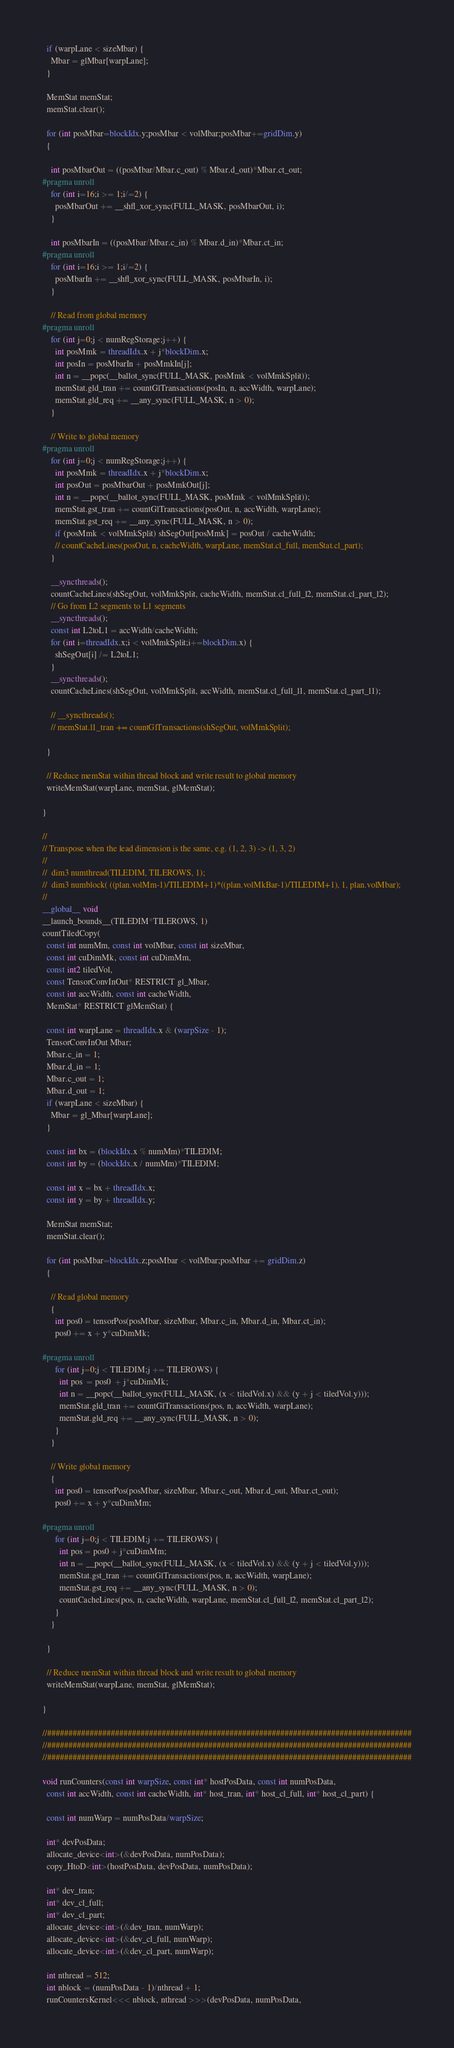Convert code to text. <code><loc_0><loc_0><loc_500><loc_500><_Cuda_>  if (warpLane < sizeMbar) {
    Mbar = glMbar[warpLane];
  }

  MemStat memStat;
  memStat.clear();

  for (int posMbar=blockIdx.y;posMbar < volMbar;posMbar+=gridDim.y)
  {

    int posMbarOut = ((posMbar/Mbar.c_out) % Mbar.d_out)*Mbar.ct_out;
#pragma unroll
    for (int i=16;i >= 1;i/=2) {
      posMbarOut += __shfl_xor_sync(FULL_MASK, posMbarOut, i);
    }

    int posMbarIn = ((posMbar/Mbar.c_in) % Mbar.d_in)*Mbar.ct_in;
#pragma unroll
    for (int i=16;i >= 1;i/=2) {
      posMbarIn += __shfl_xor_sync(FULL_MASK, posMbarIn, i);
    }

    // Read from global memory
#pragma unroll
    for (int j=0;j < numRegStorage;j++) {
      int posMmk = threadIdx.x + j*blockDim.x;
      int posIn = posMbarIn + posMmkIn[j];
      int n = __popc(__ballot_sync(FULL_MASK, posMmk < volMmkSplit));
      memStat.gld_tran += countGlTransactions(posIn, n, accWidth, warpLane);
      memStat.gld_req += __any_sync(FULL_MASK, n > 0);
    }

    // Write to global memory
#pragma unroll
    for (int j=0;j < numRegStorage;j++) {
      int posMmk = threadIdx.x + j*blockDim.x;
      int posOut = posMbarOut + posMmkOut[j];
      int n = __popc(__ballot_sync(FULL_MASK, posMmk < volMmkSplit));
      memStat.gst_tran += countGlTransactions(posOut, n, accWidth, warpLane);
      memStat.gst_req += __any_sync(FULL_MASK, n > 0);
      if (posMmk < volMmkSplit) shSegOut[posMmk] = posOut / cacheWidth;
      // countCacheLines(posOut, n, cacheWidth, warpLane, memStat.cl_full, memStat.cl_part);
    }

    __syncthreads();
    countCacheLines(shSegOut, volMmkSplit, cacheWidth, memStat.cl_full_l2, memStat.cl_part_l2);
    // Go from L2 segments to L1 segments
    __syncthreads();
    const int L2toL1 = accWidth/cacheWidth;
    for (int i=threadIdx.x;i < volMmkSplit;i+=blockDim.x) {
      shSegOut[i] /= L2toL1;
    }
    __syncthreads();
    countCacheLines(shSegOut, volMmkSplit, accWidth, memStat.cl_full_l1, memStat.cl_part_l1);

    // __syncthreads();
    // memStat.l1_tran += countGlTransactions(shSegOut, volMmkSplit);

  }

  // Reduce memStat within thread block and write result to global memory
  writeMemStat(warpLane, memStat, glMemStat);

}

//
// Transpose when the lead dimension is the same, e.g. (1, 2, 3) -> (1, 3, 2)
//
//  dim3 numthread(TILEDIM, TILEROWS, 1);
//  dim3 numblock( ((plan.volMm-1)/TILEDIM+1)*((plan.volMkBar-1)/TILEDIM+1), 1, plan.volMbar);
//
__global__ void
__launch_bounds__(TILEDIM*TILEROWS, 1)
countTiledCopy(
  const int numMm, const int volMbar, const int sizeMbar,
  const int cuDimMk, const int cuDimMm,
  const int2 tiledVol,
  const TensorConvInOut* RESTRICT gl_Mbar,
  const int accWidth, const int cacheWidth,
  MemStat* RESTRICT glMemStat) {

  const int warpLane = threadIdx.x & (warpSize - 1);
  TensorConvInOut Mbar;
  Mbar.c_in = 1;
  Mbar.d_in = 1;
  Mbar.c_out = 1;
  Mbar.d_out = 1;
  if (warpLane < sizeMbar) {
    Mbar = gl_Mbar[warpLane];
  }

  const int bx = (blockIdx.x % numMm)*TILEDIM;
  const int by = (blockIdx.x / numMm)*TILEDIM;

  const int x = bx + threadIdx.x;
  const int y = by + threadIdx.y;

  MemStat memStat;
  memStat.clear();

  for (int posMbar=blockIdx.z;posMbar < volMbar;posMbar += gridDim.z)
  {

    // Read global memory
    {
      int pos0 = tensorPos(posMbar, sizeMbar, Mbar.c_in, Mbar.d_in, Mbar.ct_in);
      pos0 += x + y*cuDimMk;

#pragma unroll
      for (int j=0;j < TILEDIM;j += TILEROWS) {
        int pos  = pos0  + j*cuDimMk;
        int n = __popc(__ballot_sync(FULL_MASK, (x < tiledVol.x) && (y + j < tiledVol.y)));
        memStat.gld_tran += countGlTransactions(pos, n, accWidth, warpLane);
        memStat.gld_req += __any_sync(FULL_MASK, n > 0);
      }
    }

    // Write global memory
    {
      int pos0 = tensorPos(posMbar, sizeMbar, Mbar.c_out, Mbar.d_out, Mbar.ct_out);
      pos0 += x + y*cuDimMm;

#pragma unroll
      for (int j=0;j < TILEDIM;j += TILEROWS) {
        int pos = pos0 + j*cuDimMm;
        int n = __popc(__ballot_sync(FULL_MASK, (x < tiledVol.x) && (y + j < tiledVol.y)));
        memStat.gst_tran += countGlTransactions(pos, n, accWidth, warpLane);
        memStat.gst_req += __any_sync(FULL_MASK, n > 0);
        countCacheLines(pos, n, cacheWidth, warpLane, memStat.cl_full_l2, memStat.cl_part_l2);
      }
    }

  }

  // Reduce memStat within thread block and write result to global memory
  writeMemStat(warpLane, memStat, glMemStat);

}

//######################################################################################
//######################################################################################
//######################################################################################

void runCounters(const int warpSize, const int* hostPosData, const int numPosData,
  const int accWidth, const int cacheWidth, int* host_tran, int* host_cl_full, int* host_cl_part) {

  const int numWarp = numPosData/warpSize;

  int* devPosData;
  allocate_device<int>(&devPosData, numPosData);
  copy_HtoD<int>(hostPosData, devPosData, numPosData);

  int* dev_tran;
  int* dev_cl_full;
  int* dev_cl_part;
  allocate_device<int>(&dev_tran, numWarp);
  allocate_device<int>(&dev_cl_full, numWarp);
  allocate_device<int>(&dev_cl_part, numWarp);

  int nthread = 512;
  int nblock = (numPosData - 1)/nthread + 1;
  runCountersKernel<<< nblock, nthread >>>(devPosData, numPosData,</code> 